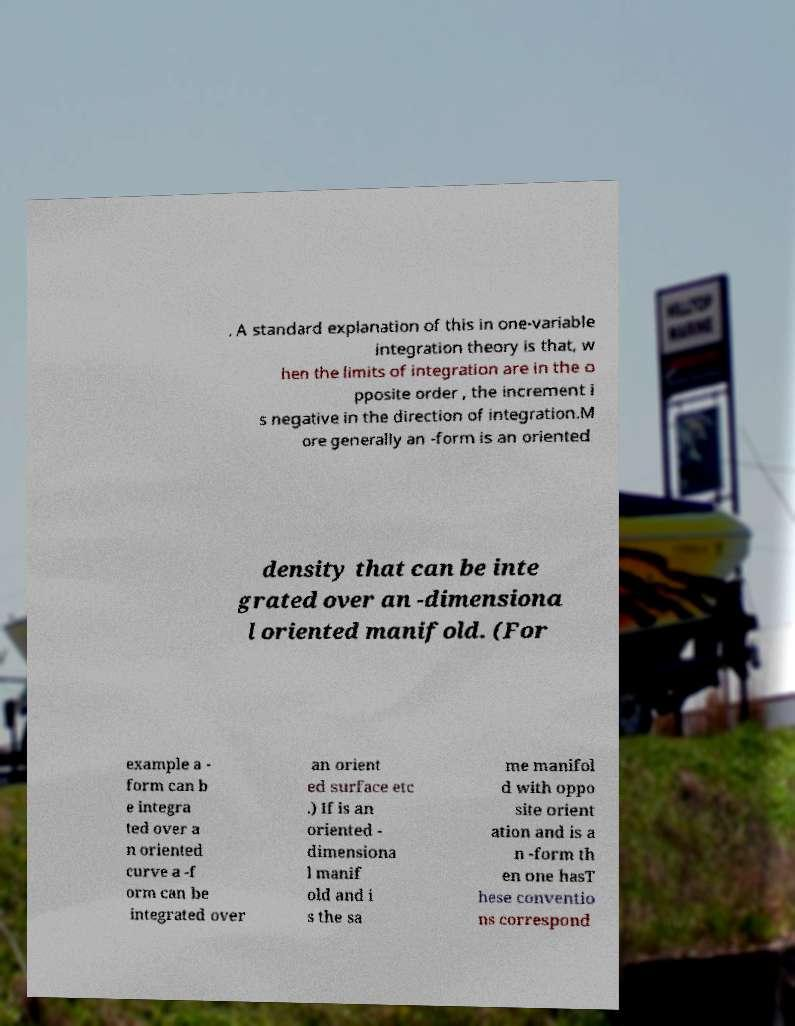Can you read and provide the text displayed in the image?This photo seems to have some interesting text. Can you extract and type it out for me? . A standard explanation of this in one-variable integration theory is that, w hen the limits of integration are in the o pposite order , the increment i s negative in the direction of integration.M ore generally an -form is an oriented density that can be inte grated over an -dimensiona l oriented manifold. (For example a - form can b e integra ted over a n oriented curve a -f orm can be integrated over an orient ed surface etc .) If is an oriented - dimensiona l manif old and i s the sa me manifol d with oppo site orient ation and is a n -form th en one hasT hese conventio ns correspond 